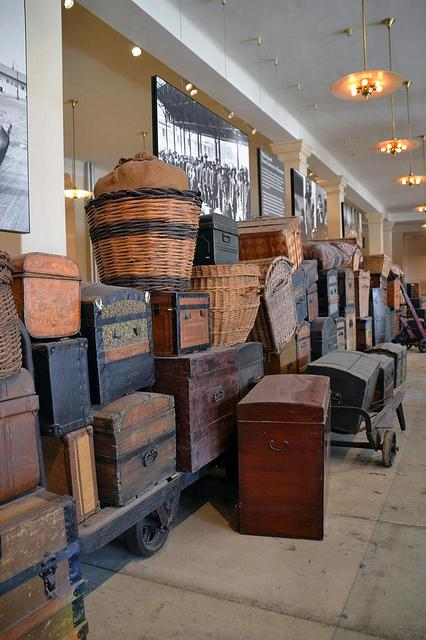What are the largest rectangular clothing item storage pieces called? Please explain your reasoning. trunks. They are usually heavy and difficult to move because they only have small handles on the sides. 